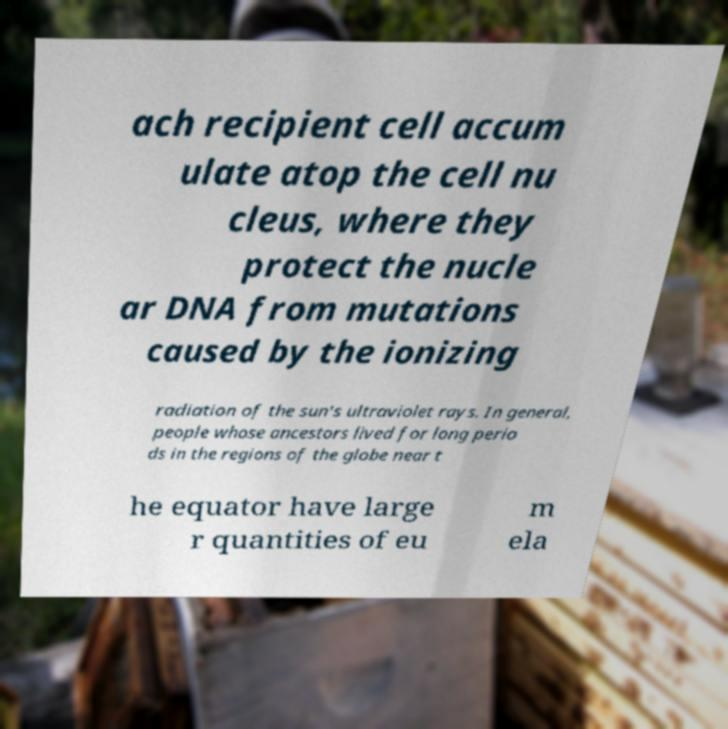Could you extract and type out the text from this image? ach recipient cell accum ulate atop the cell nu cleus, where they protect the nucle ar DNA from mutations caused by the ionizing radiation of the sun's ultraviolet rays. In general, people whose ancestors lived for long perio ds in the regions of the globe near t he equator have large r quantities of eu m ela 